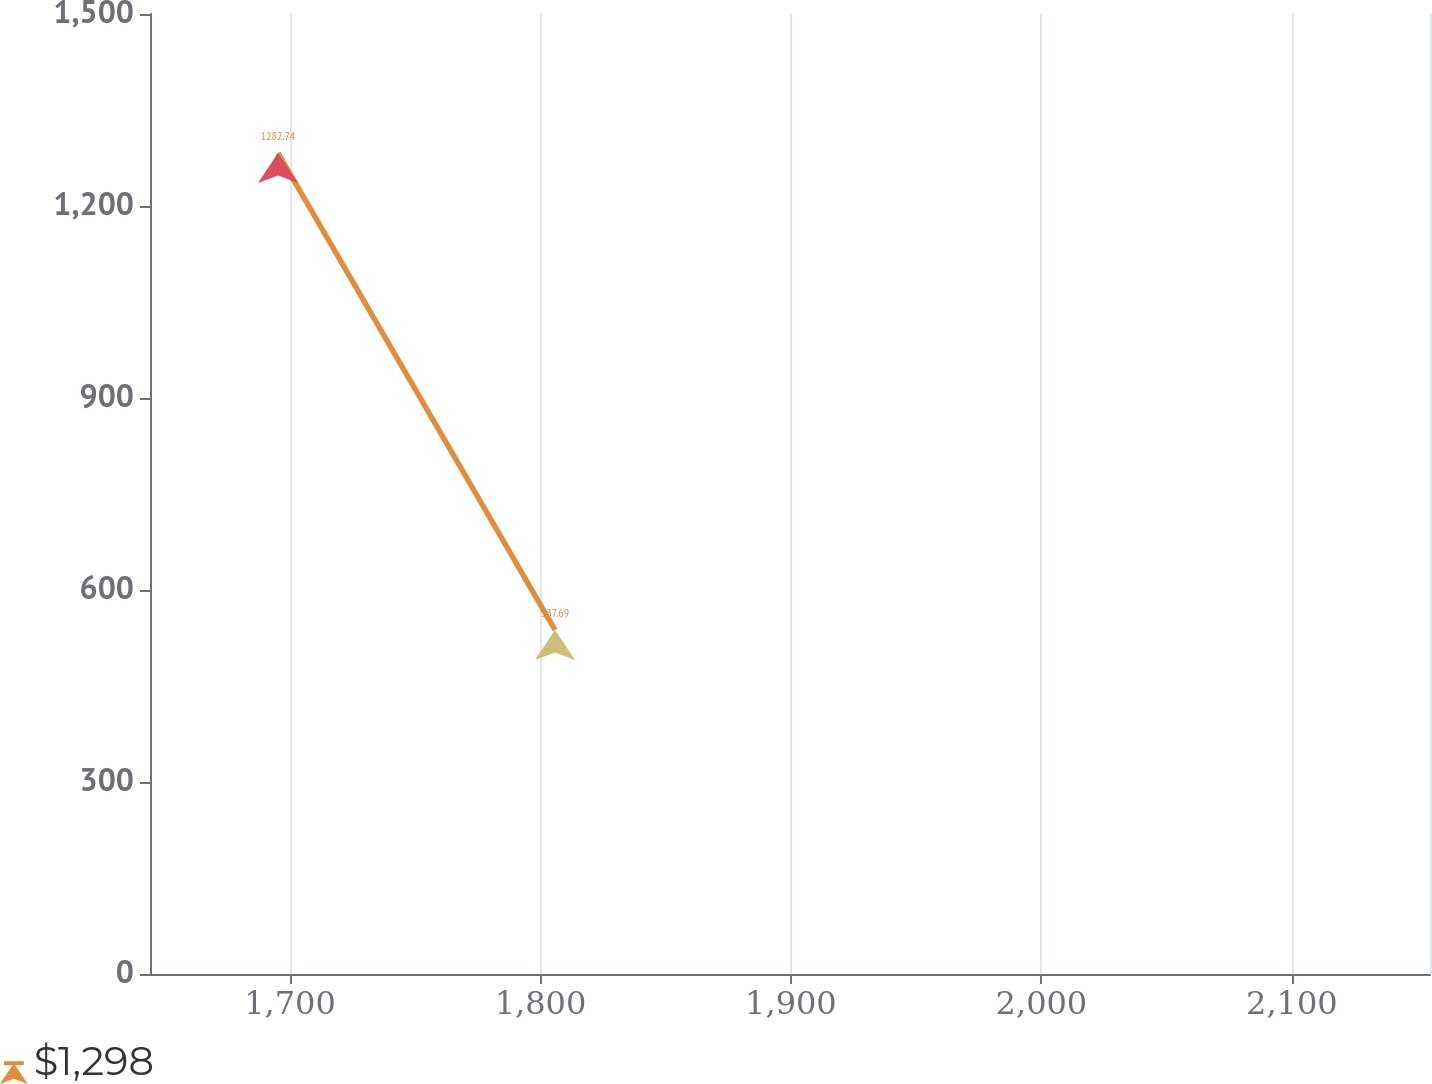Convert chart. <chart><loc_0><loc_0><loc_500><loc_500><line_chart><ecel><fcel>$1,298<nl><fcel>1695.23<fcel>1282.74<nl><fcel>1805.83<fcel>537.69<nl><fcel>2206.24<fcel>38.92<nl></chart> 